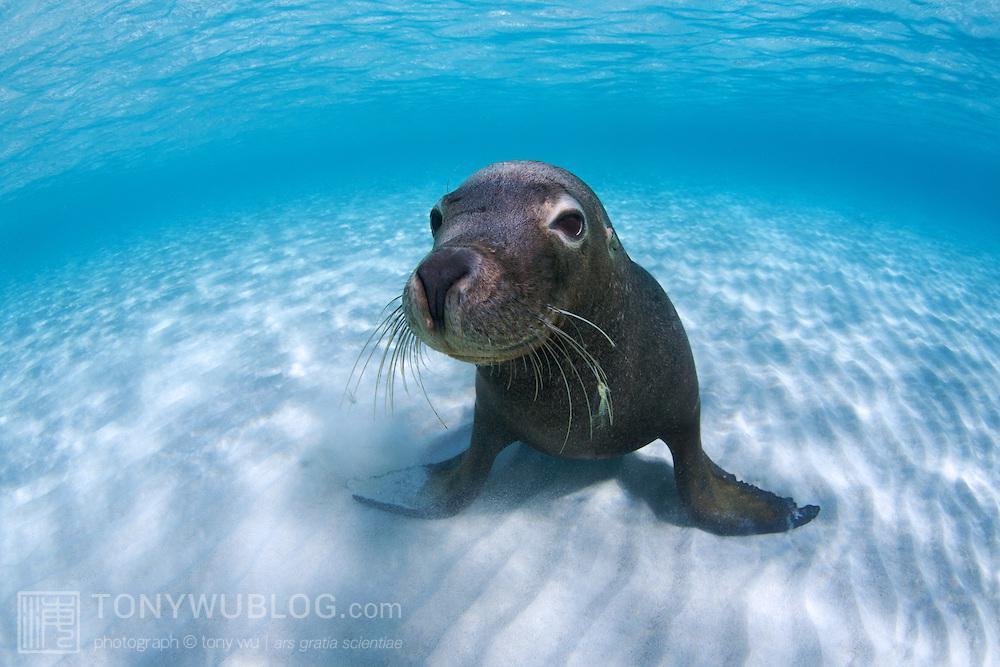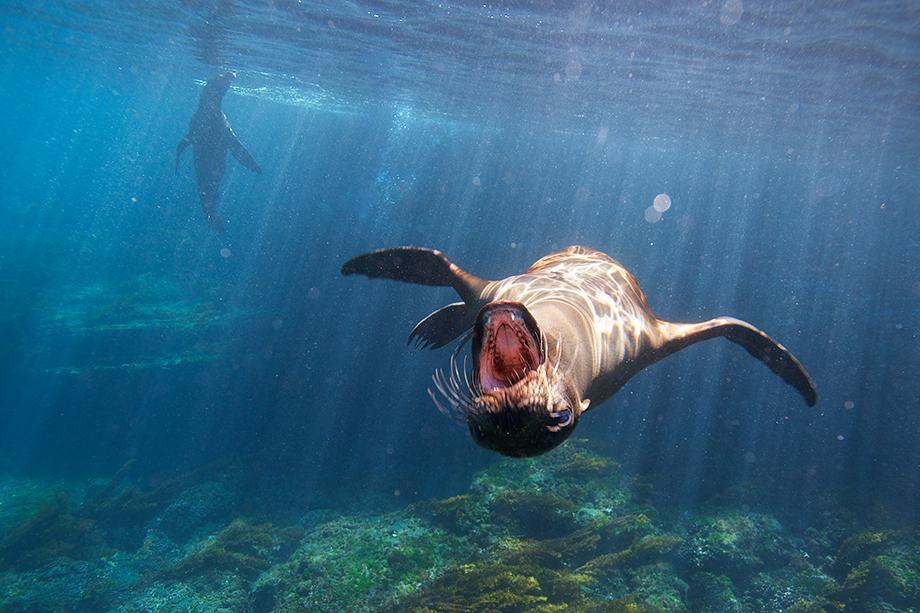The first image is the image on the left, the second image is the image on the right. Examine the images to the left and right. Is the description "None of the images have more than two seals." accurate? Answer yes or no. Yes. The first image is the image on the left, the second image is the image on the right. For the images shown, is this caption "In the left image there is one seal on top of another seal." true? Answer yes or no. No. 